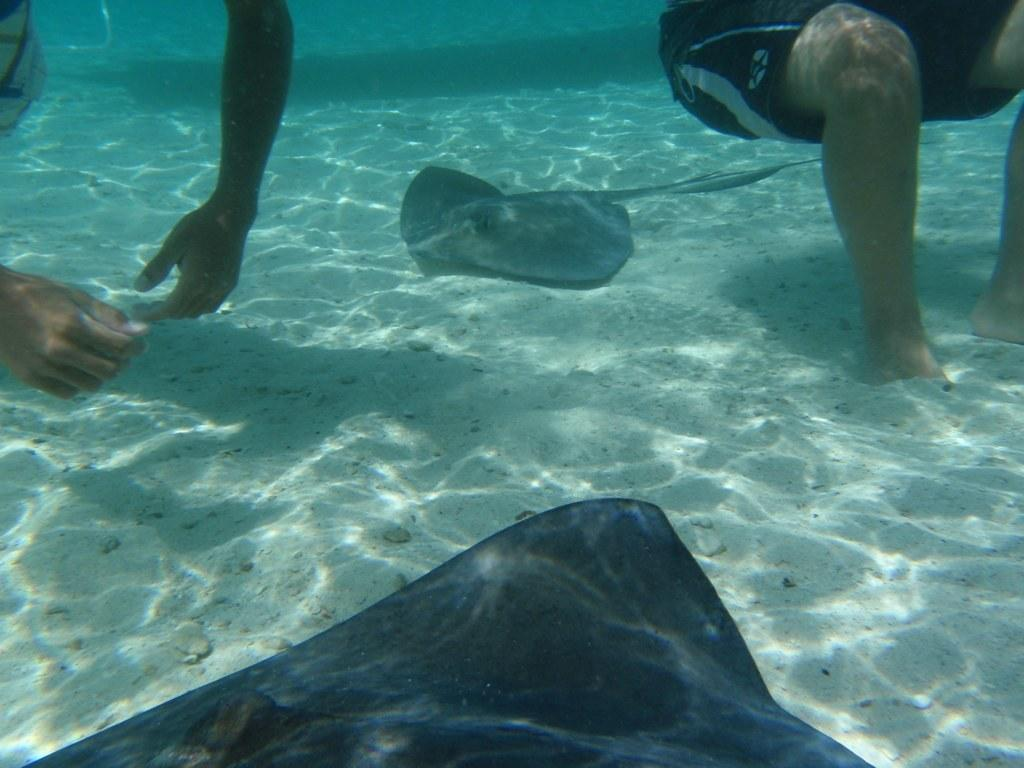What type of environment is depicted in the image? The image shows a water and sand environment. What can be seen in the water in the image? There is a fish visible in the water. What body parts of a person can be seen in the image? The hands and legs of a person are visible in the image. What type of paint is being used to color the territory in the image? There is no paint or territory present in the image; it features a water and sand environment with a fish and a person's body parts. What type of fowl can be seen in the image? There are no fowl present in the image. 